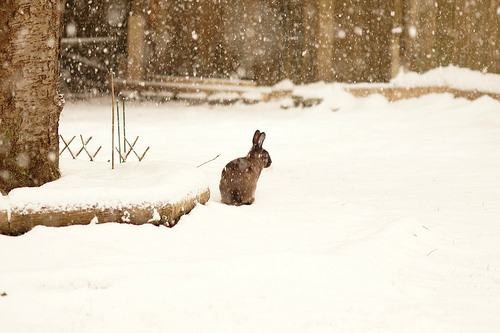<image>
Is the rabbit on the platform? No. The rabbit is not positioned on the platform. They may be near each other, but the rabbit is not supported by or resting on top of the platform. 